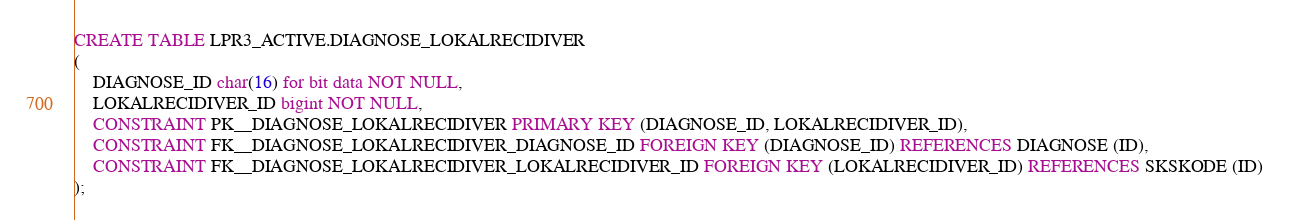<code> <loc_0><loc_0><loc_500><loc_500><_SQL_>CREATE TABLE LPR3_ACTIVE.DIAGNOSE_LOKALRECIDIVER
(
    DIAGNOSE_ID char(16) for bit data NOT NULL,
    LOKALRECIDIVER_ID bigint NOT NULL,
    CONSTRAINT PK__DIAGNOSE_LOKALRECIDIVER PRIMARY KEY (DIAGNOSE_ID, LOKALRECIDIVER_ID),
    CONSTRAINT FK__DIAGNOSE_LOKALRECIDIVER_DIAGNOSE_ID FOREIGN KEY (DIAGNOSE_ID) REFERENCES DIAGNOSE (ID),
    CONSTRAINT FK__DIAGNOSE_LOKALRECIDIVER_LOKALRECIDIVER_ID FOREIGN KEY (LOKALRECIDIVER_ID) REFERENCES SKSKODE (ID)
);</code> 